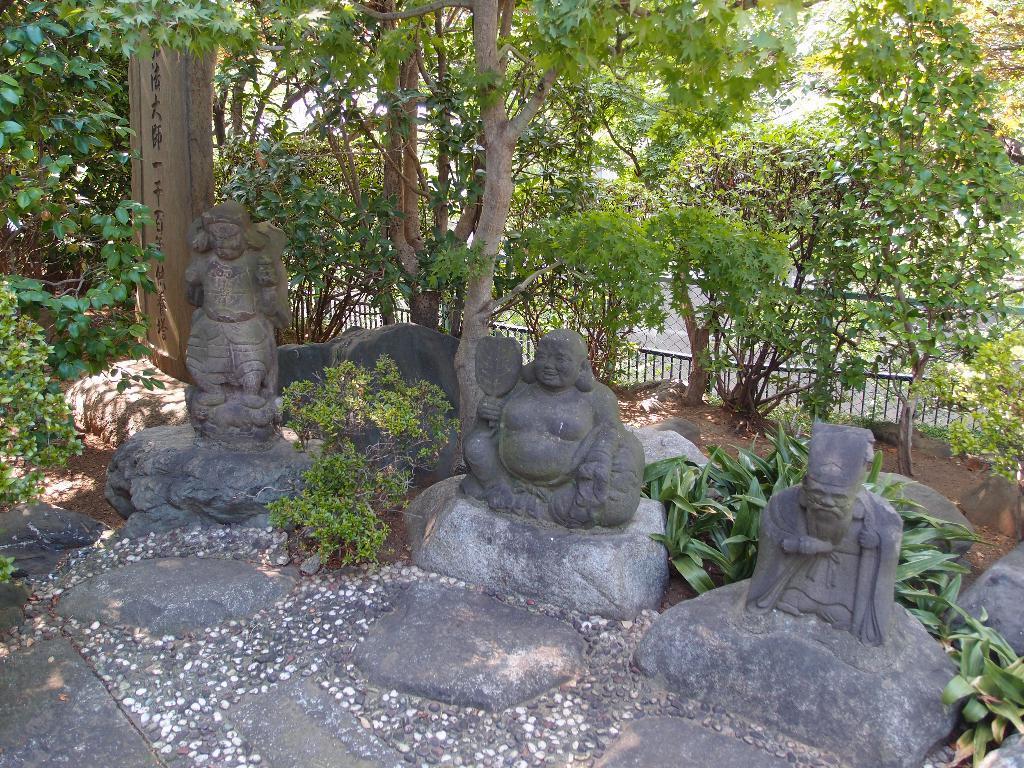Please provide a concise description of this image. In this image I can see rock sculptures, trees and fence at the back. 